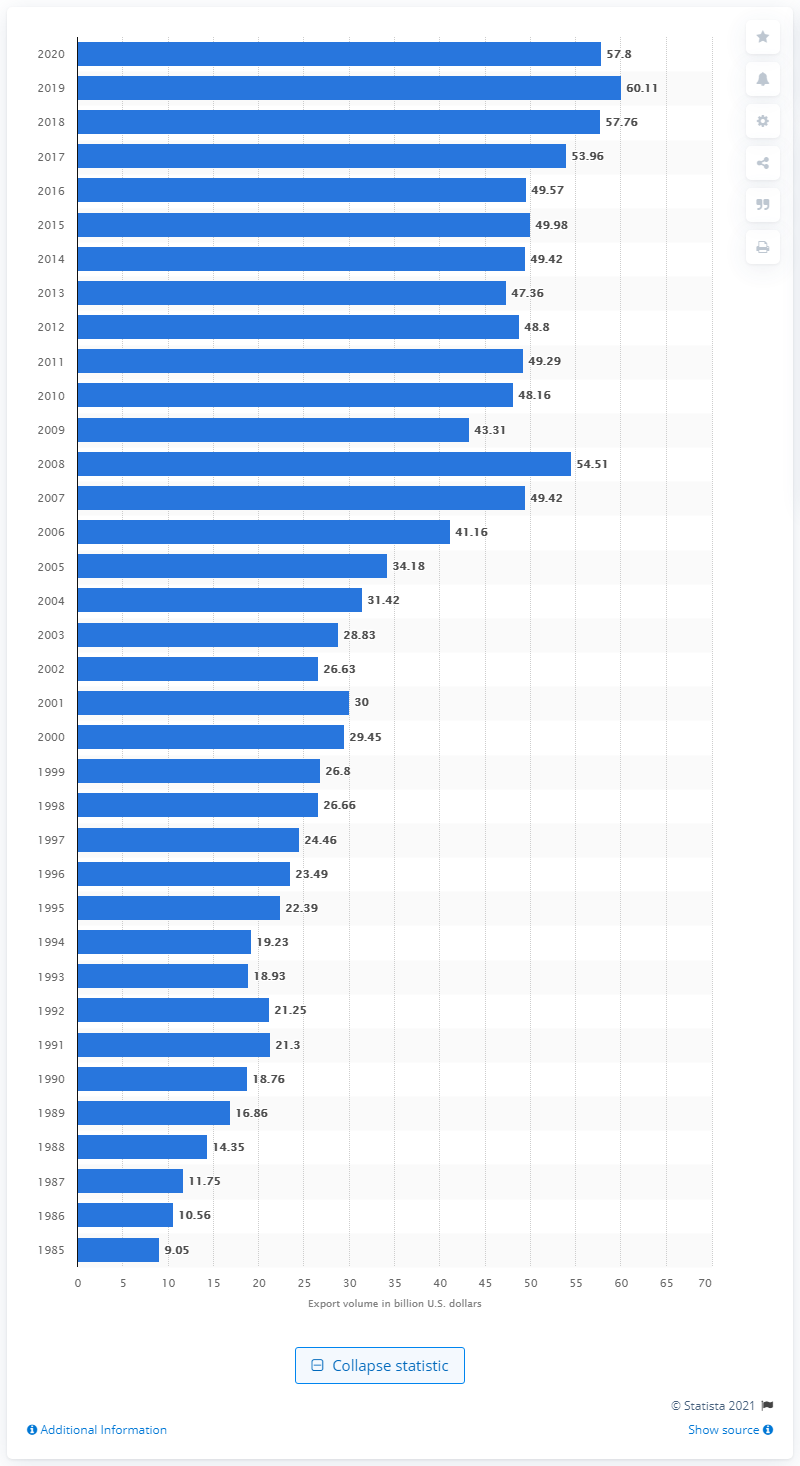Highlight a few significant elements in this photo. In 2020, the United States exported 57.8 billion dollars worth of goods to Germany. 